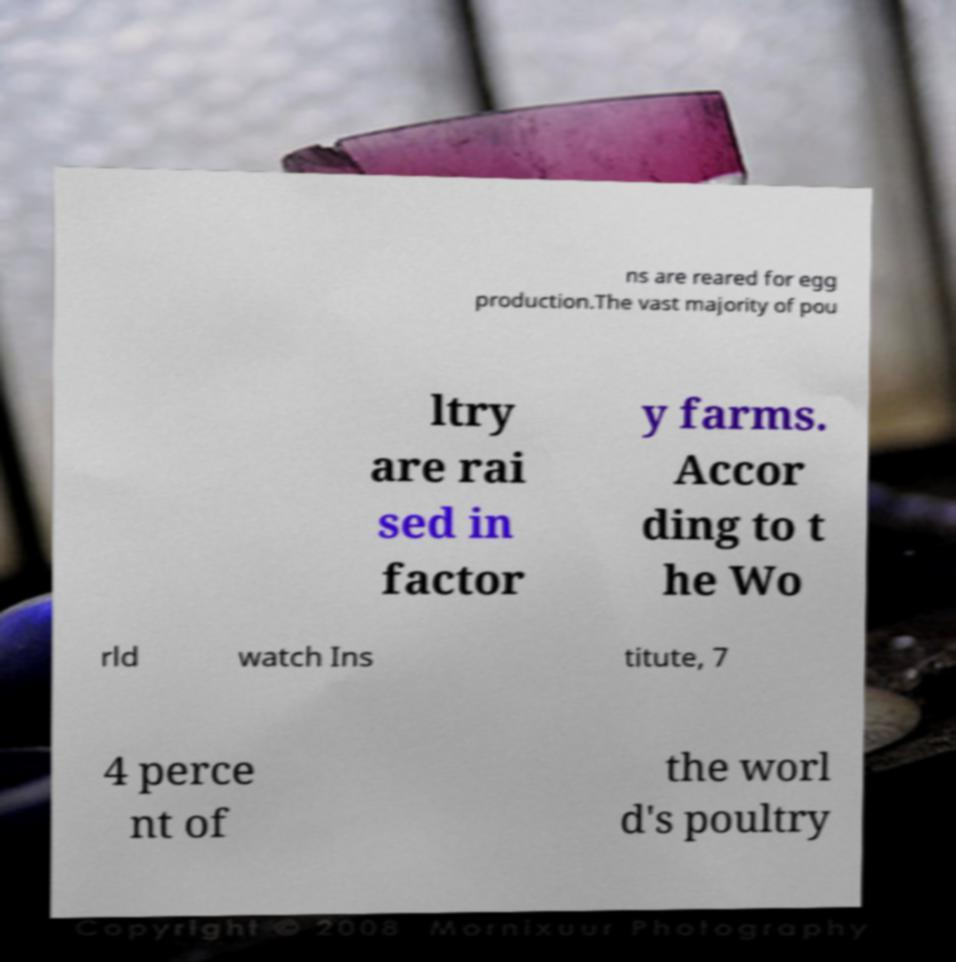Could you assist in decoding the text presented in this image and type it out clearly? ns are reared for egg production.The vast majority of pou ltry are rai sed in factor y farms. Accor ding to t he Wo rld watch Ins titute, 7 4 perce nt of the worl d's poultry 